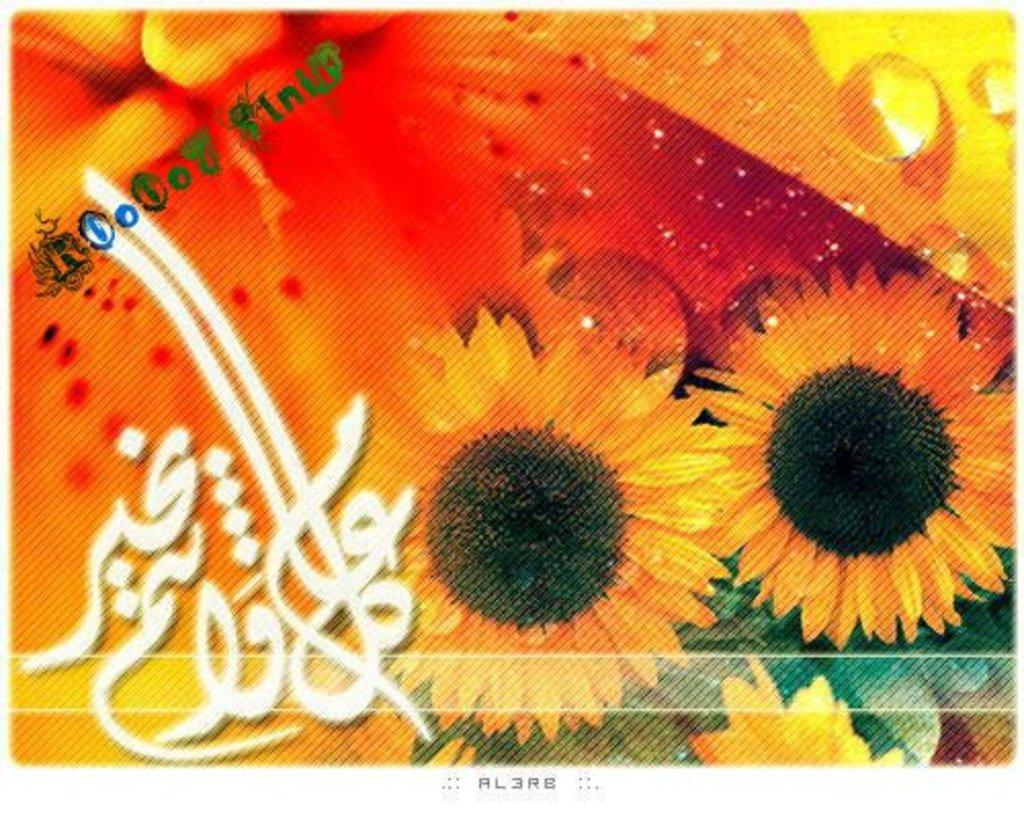What type of flora can be seen in the image? There are flowers in the image. What colors are the flowers? The flowers are orange and black in color. Can you describe any other details visible in the image? There are water drops visible in the image. Is there any text present in the image? Yes, there is text written on the image. What type of egg is being served for dinner in the image? There is no egg or dinner scene present in the image; it features flowers, water drops, and text. 